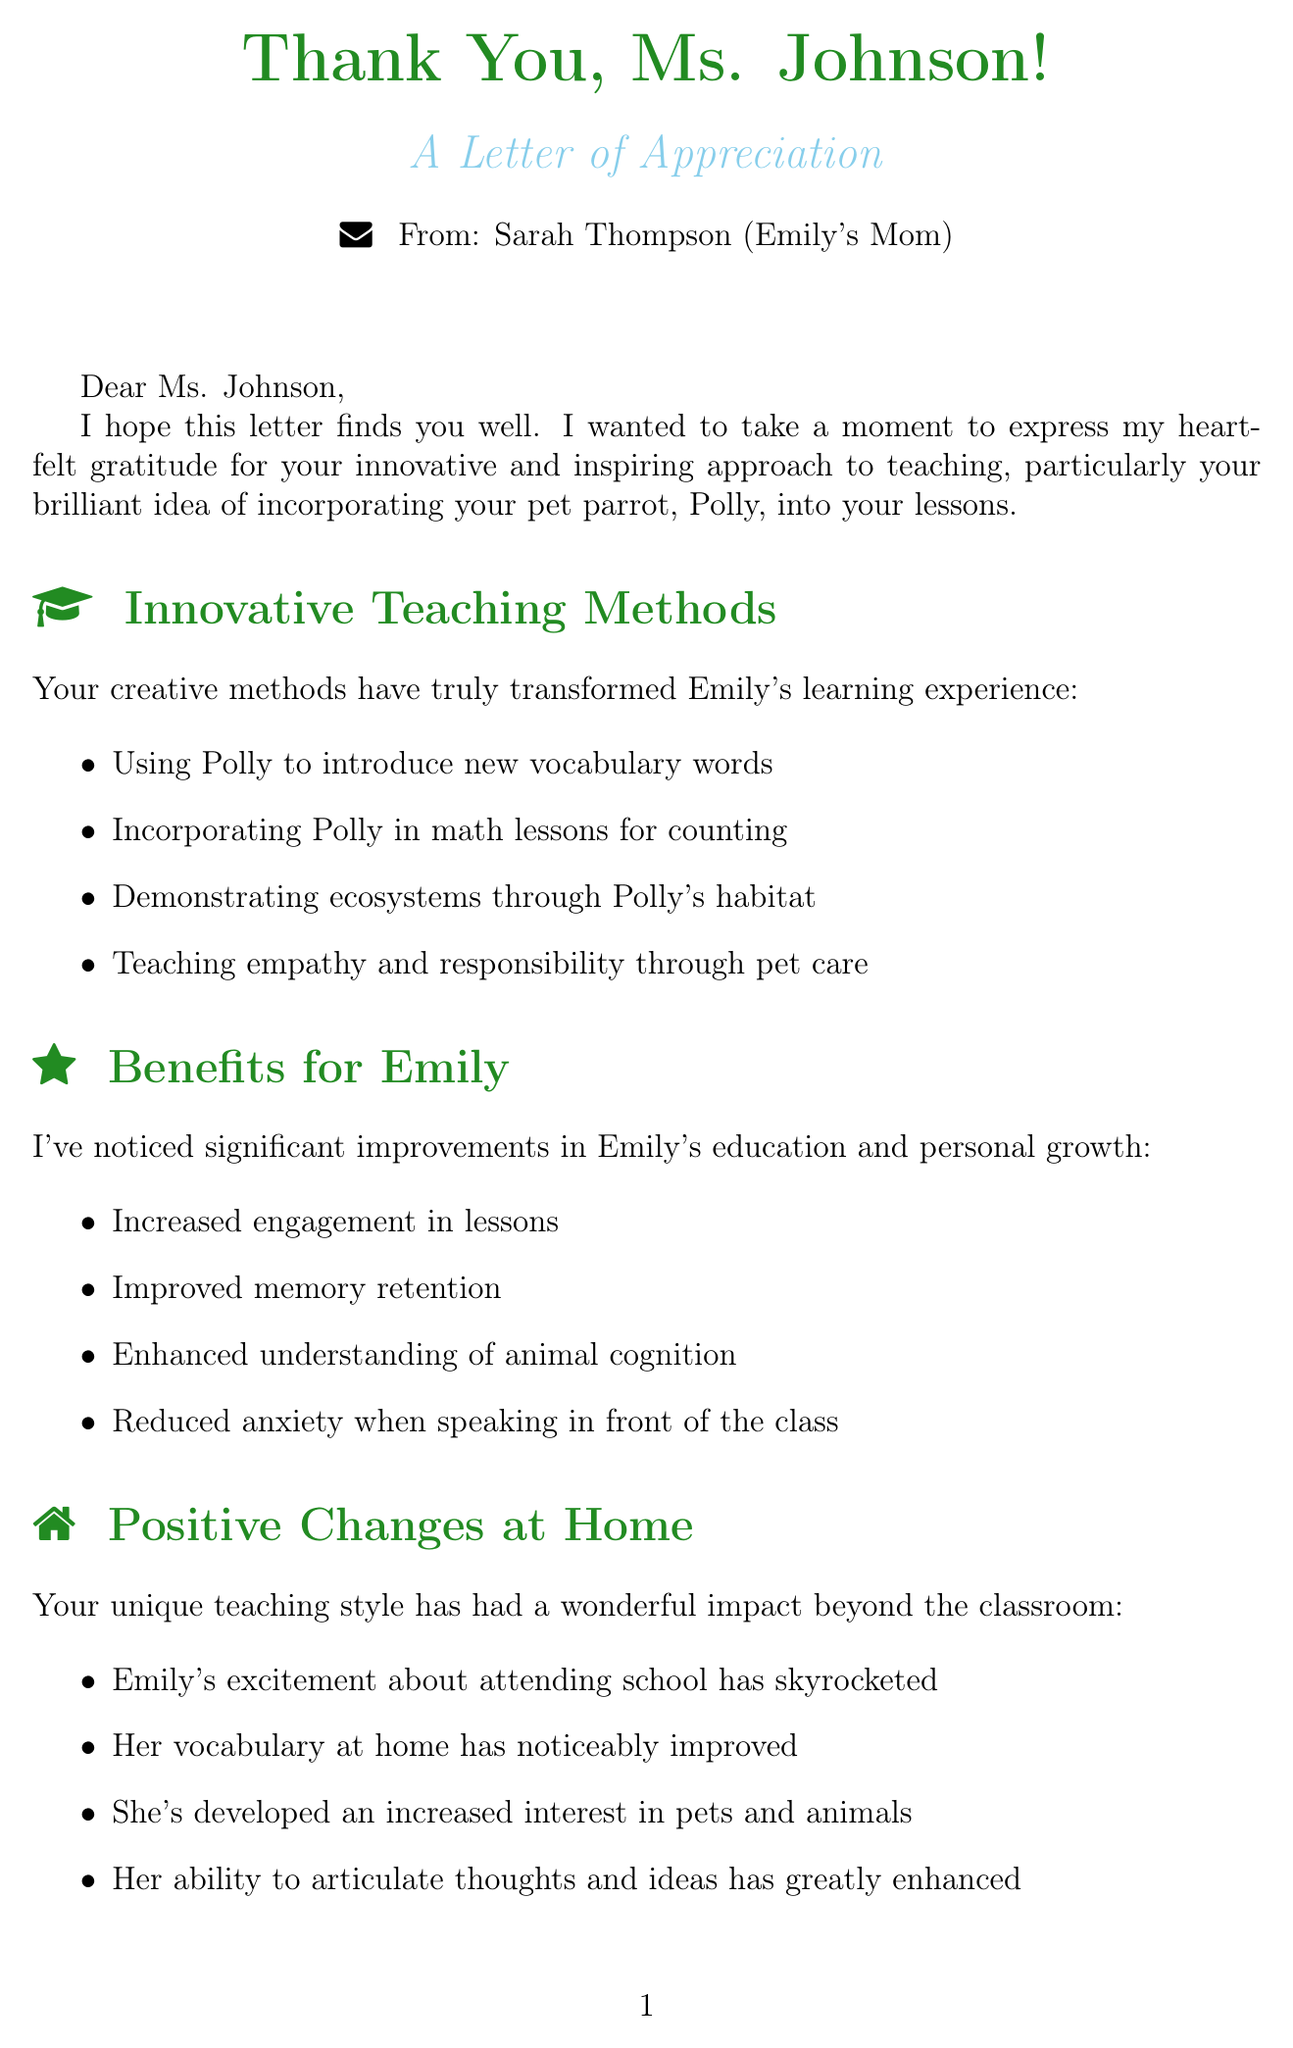What is the teacher's name? The teacher's name is mentioned at the beginning of the letter as Ms. Johnson.
Answer: Ms. Johnson What is the name of the student? The student's name is stated in the introduction of the letter as Emily.
Answer: Emily What is the pet parrot's name? The parrot's name is mentioned throughout the letter as Polly.
Answer: Polly What is one benefit observed in Emily's learning? One of the benefits described in the letter is increased engagement in lessons.
Answer: Increased engagement in lessons What innovative method is used to introduce new vocabulary? One of the innovative methods described is using the parrot to introduce new words.
Answer: Using the parrot to introduce new words What observation did the parent make about Emily's excitement? The letter mentions that Emily's excitement about attending school has skyrocketed.
Answer: Skyrocketed What community impact is mentioned in the letter? The letter states that the school has been featured in the local newspaper for its unique learning environment.
Answer: Featured in the local newspaper for its unique learning environment What future idea is proposed in the document? The letter proposes creating a classroom blog about Polly's adventures.
Answer: Creating a classroom blog about Polly's adventures What is the tone of the letter? The tone of the letter is one of gratitude and appreciation towards the teacher's efforts.
Answer: Gratitude and appreciation 